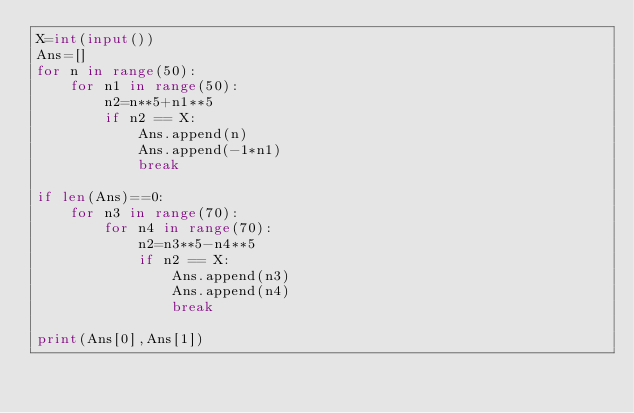<code> <loc_0><loc_0><loc_500><loc_500><_Python_>X=int(input())
Ans=[]
for n in range(50):
    for n1 in range(50):
        n2=n**5+n1**5
        if n2 == X:
            Ans.append(n)
            Ans.append(-1*n1)
            break

if len(Ans)==0:
    for n3 in range(70):
        for n4 in range(70):
            n2=n3**5-n4**5
            if n2 == X:
                Ans.append(n3)
                Ans.append(n4)
                break

print(Ans[0],Ans[1])
</code> 